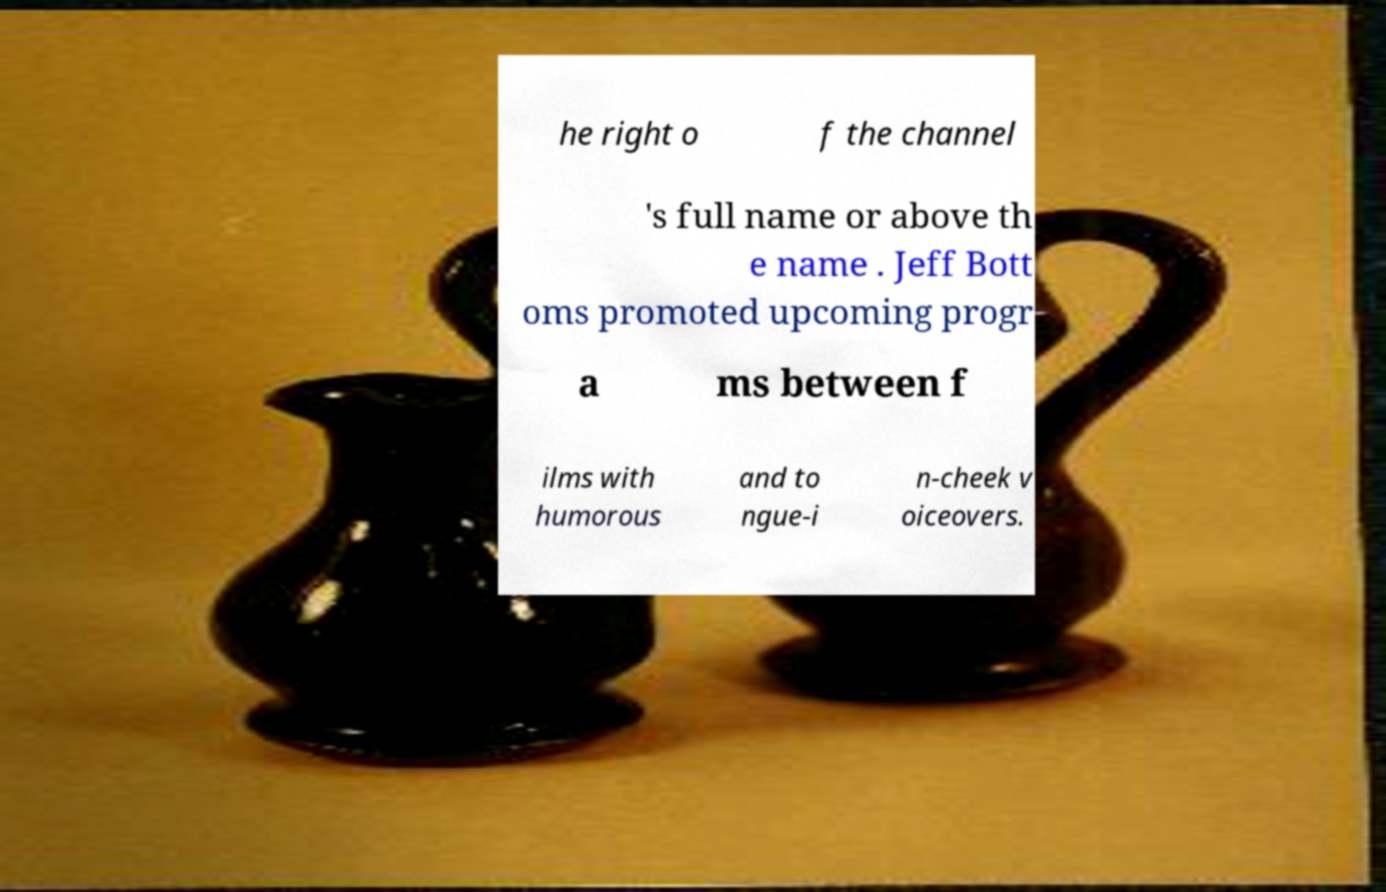There's text embedded in this image that I need extracted. Can you transcribe it verbatim? he right o f the channel 's full name or above th e name . Jeff Bott oms promoted upcoming progr a ms between f ilms with humorous and to ngue-i n-cheek v oiceovers. 